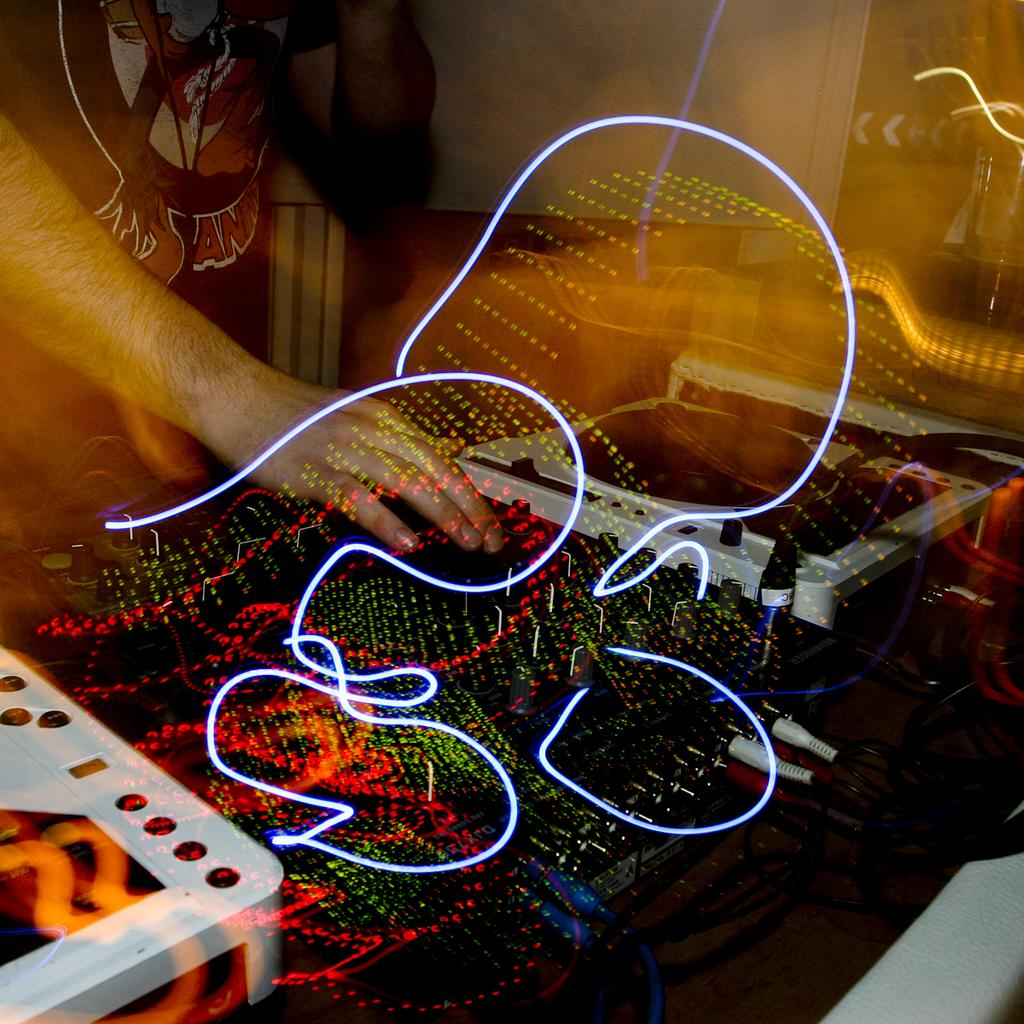What is the main subject of the image? The main subject of the image is a DJ. What is the DJ doing in the image? The DJ is playing music in the image. What is located in front of the DJ? There is a table in front of the DJ. What can be found on top of the table? There are objects on top of the table. How does the DJ express anger while playing music in the image? There is no indication of anger in the image; the DJ is simply playing music. What type of stamp is visible on the table in the image? There is no stamp present in the image; only objects are visible on the table. 